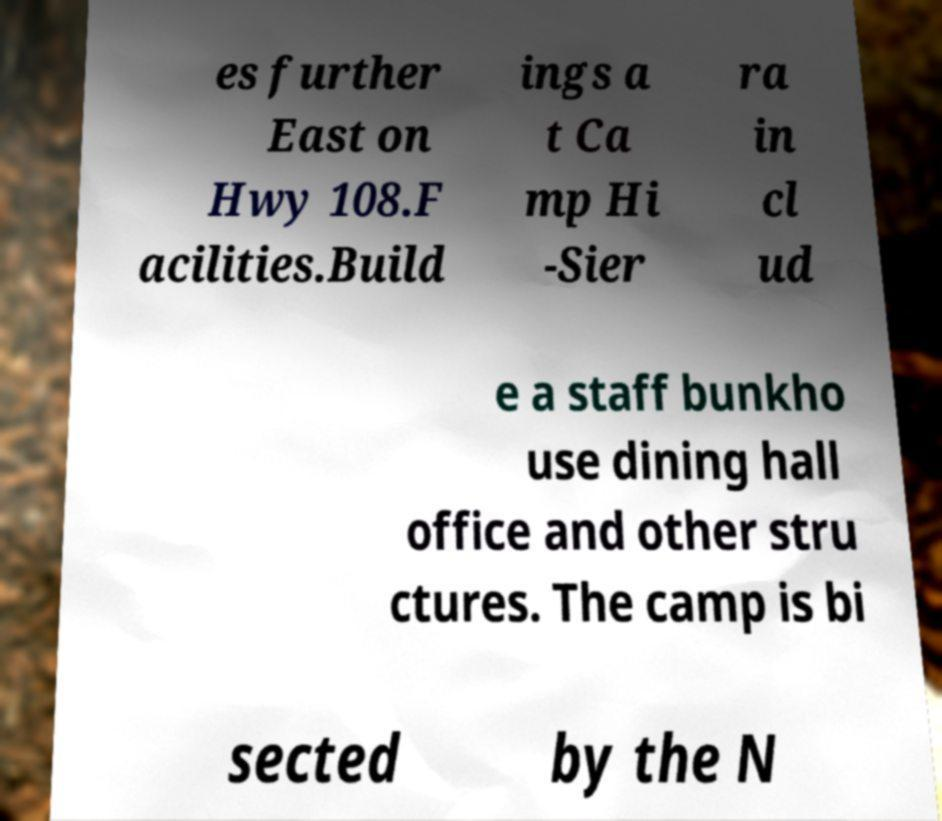Could you assist in decoding the text presented in this image and type it out clearly? es further East on Hwy 108.F acilities.Build ings a t Ca mp Hi -Sier ra in cl ud e a staff bunkho use dining hall office and other stru ctures. The camp is bi sected by the N 